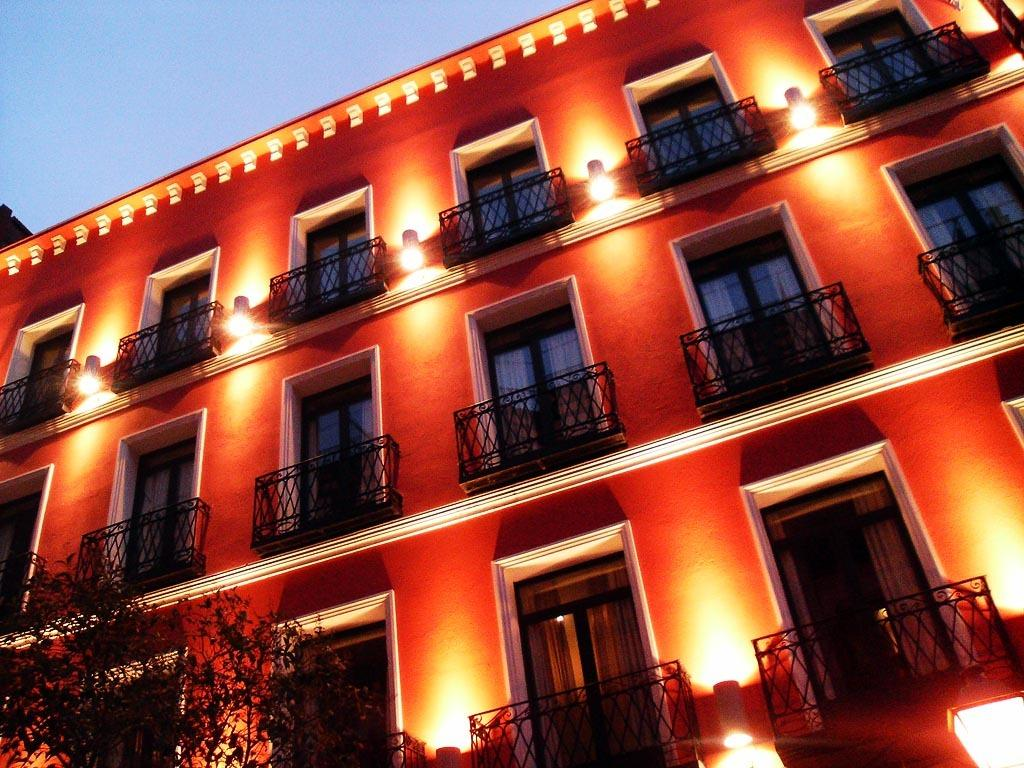What is the main structure in the image? There is a building in the image. What can be observed about the windows of the building? The windows of the building have lights. Where is the tree located in the image? There is a tree in the left bottom corner of the image. What part of the natural environment is visible in the image? The sky is visible in the top left corner of the image. Can you see any quivers or fairies sitting on the throne in the image? There is no throne, quiver, or fairies present in the image. 